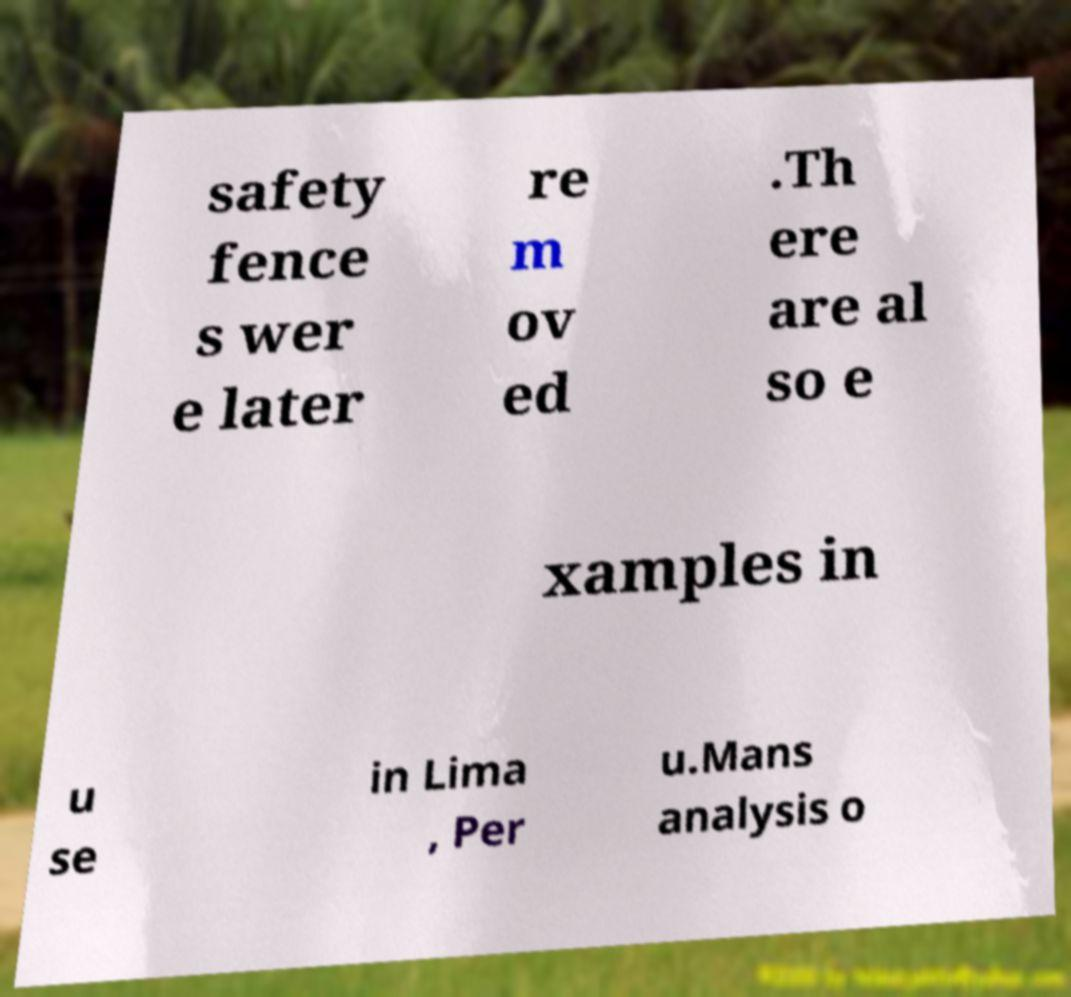Can you accurately transcribe the text from the provided image for me? safety fence s wer e later re m ov ed .Th ere are al so e xamples in u se in Lima , Per u.Mans analysis o 